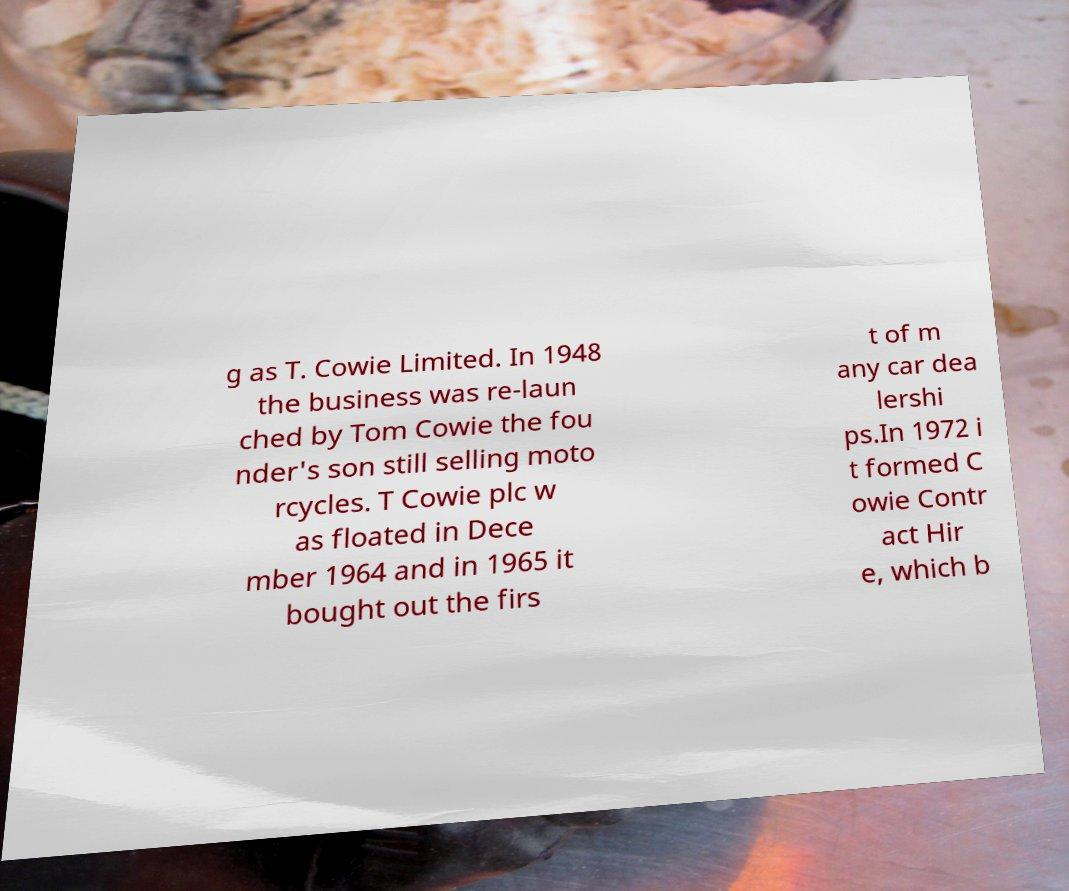What messages or text are displayed in this image? I need them in a readable, typed format. g as T. Cowie Limited. In 1948 the business was re-laun ched by Tom Cowie the fou nder's son still selling moto rcycles. T Cowie plc w as floated in Dece mber 1964 and in 1965 it bought out the firs t of m any car dea lershi ps.In 1972 i t formed C owie Contr act Hir e, which b 